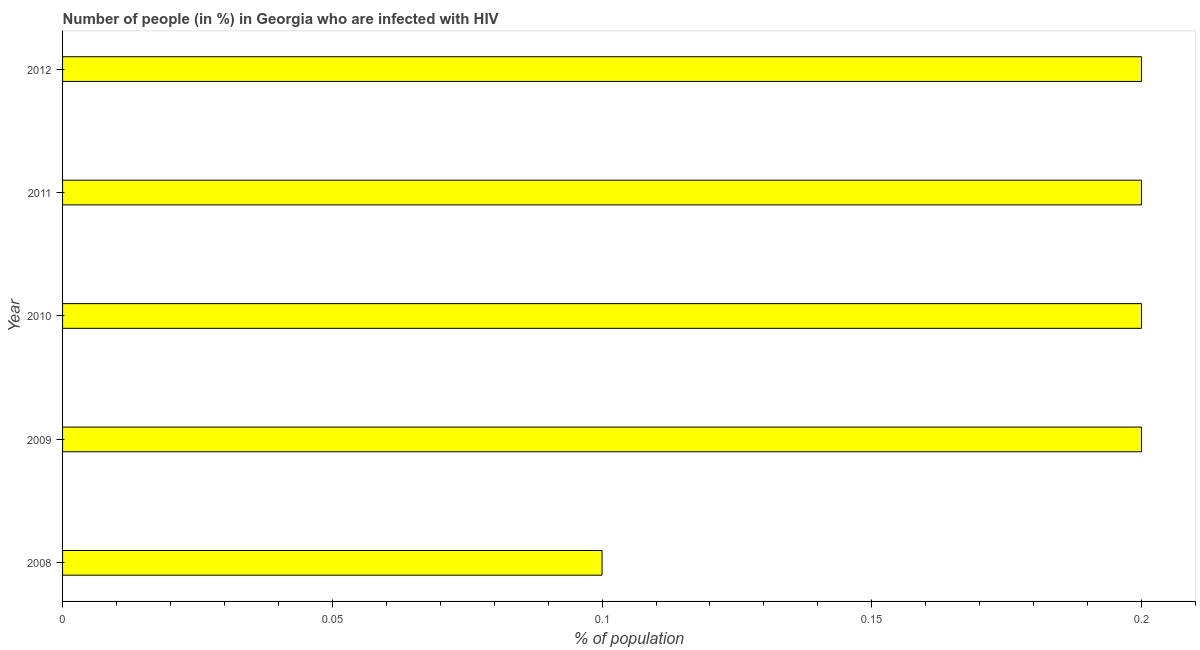Does the graph contain grids?
Provide a succinct answer. No. What is the title of the graph?
Ensure brevity in your answer.  Number of people (in %) in Georgia who are infected with HIV. What is the label or title of the X-axis?
Offer a terse response. % of population. What is the label or title of the Y-axis?
Keep it short and to the point. Year. What is the number of people infected with hiv in 2008?
Your response must be concise. 0.1. Across all years, what is the minimum number of people infected with hiv?
Your answer should be very brief. 0.1. In which year was the number of people infected with hiv minimum?
Your answer should be very brief. 2008. What is the sum of the number of people infected with hiv?
Offer a very short reply. 0.9. What is the difference between the number of people infected with hiv in 2010 and 2011?
Offer a terse response. 0. What is the average number of people infected with hiv per year?
Give a very brief answer. 0.18. What is the median number of people infected with hiv?
Provide a succinct answer. 0.2. In how many years, is the number of people infected with hiv greater than 0.1 %?
Offer a very short reply. 4. What is the difference between the highest and the second highest number of people infected with hiv?
Provide a succinct answer. 0. In how many years, is the number of people infected with hiv greater than the average number of people infected with hiv taken over all years?
Give a very brief answer. 4. How many years are there in the graph?
Your answer should be very brief. 5. What is the difference between two consecutive major ticks on the X-axis?
Offer a very short reply. 0.05. Are the values on the major ticks of X-axis written in scientific E-notation?
Offer a terse response. No. What is the % of population in 2008?
Your answer should be very brief. 0.1. What is the % of population of 2011?
Your answer should be very brief. 0.2. What is the difference between the % of population in 2008 and 2010?
Give a very brief answer. -0.1. What is the difference between the % of population in 2008 and 2011?
Ensure brevity in your answer.  -0.1. What is the difference between the % of population in 2009 and 2010?
Offer a terse response. 0. What is the difference between the % of population in 2009 and 2012?
Give a very brief answer. 0. What is the difference between the % of population in 2010 and 2011?
Give a very brief answer. 0. What is the ratio of the % of population in 2008 to that in 2010?
Give a very brief answer. 0.5. What is the ratio of the % of population in 2008 to that in 2011?
Your answer should be very brief. 0.5. What is the ratio of the % of population in 2009 to that in 2010?
Your answer should be very brief. 1. What is the ratio of the % of population in 2010 to that in 2011?
Provide a succinct answer. 1. What is the ratio of the % of population in 2010 to that in 2012?
Provide a short and direct response. 1. What is the ratio of the % of population in 2011 to that in 2012?
Make the answer very short. 1. 